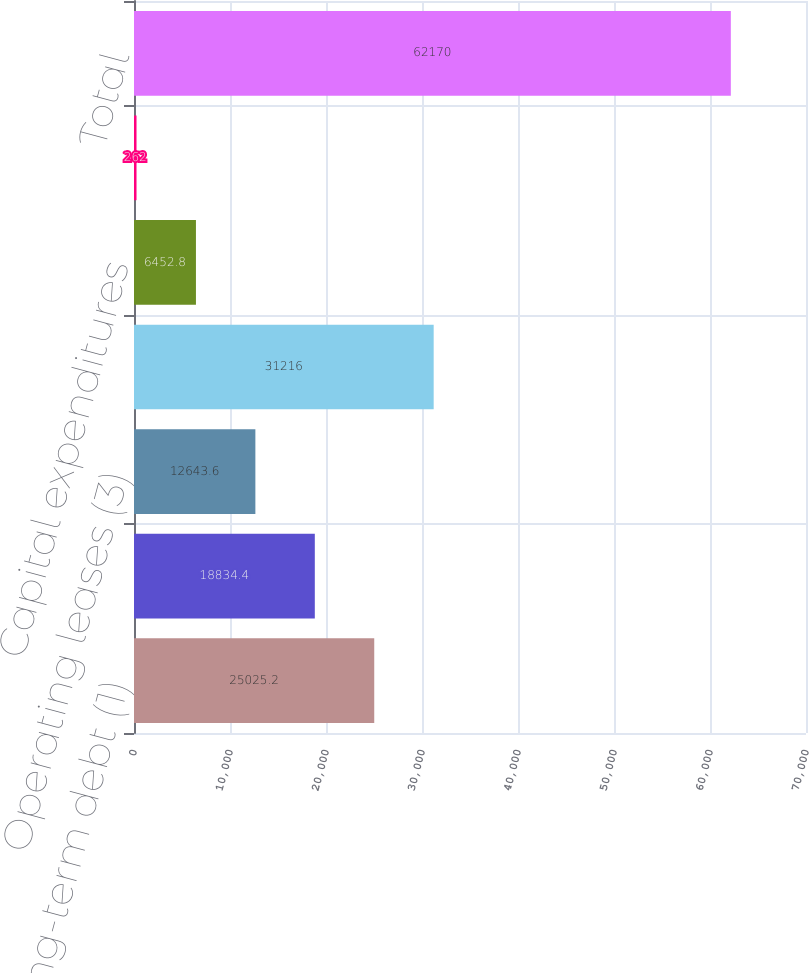Convert chart to OTSL. <chart><loc_0><loc_0><loc_500><loc_500><bar_chart><fcel>Long-term debt (1)<fcel>Interest on long-term debt (2)<fcel>Operating leases (3)<fcel>Fuel and purchased power (4)<fcel>Capital expenditures<fcel>Other (5)<fcel>Total<nl><fcel>25025.2<fcel>18834.4<fcel>12643.6<fcel>31216<fcel>6452.8<fcel>262<fcel>62170<nl></chart> 